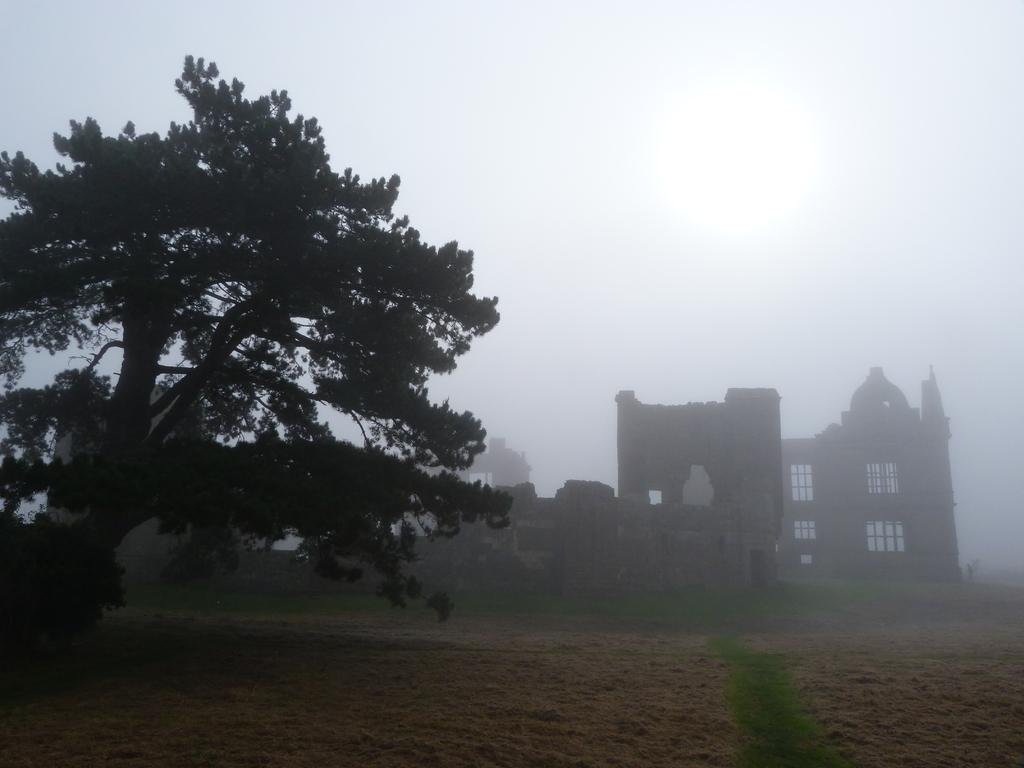What type of natural elements can be seen in the background of the image? There are trees in the background of the image. What type of man-made structures can be seen in the background of the image? There are buildings in the background of the image. Where are your friends sitting in the image? There are no friends present in the image. What type of garden can be seen in the image? There is no garden present in the image. 